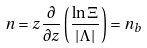<formula> <loc_0><loc_0><loc_500><loc_500>n = z \frac { \partial } { \partial z } \left ( \frac { \ln \Xi } { | \Lambda | } \right ) = n _ { b }</formula> 